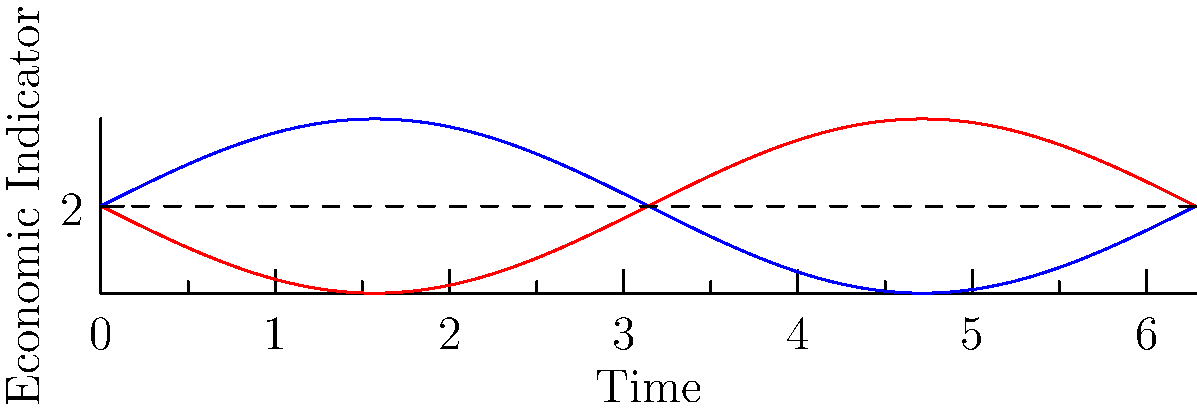Consider the time series data represented by the blue curve in the graph, which shows economic fluctuations around a trend line (dashed). The red curve represents the reflection of the original series across the trend line. What economic insight can be gained by analyzing the symmetry between these two curves, and how might this reflection technique be used in econometric modeling to assess the nature of economic cycles? To answer this question, we need to consider several aspects of the graph and its economic implications:

1. Trend line: The dashed line represents the long-term trend of the economic indicator. In econometric modeling, this could be interpreted as the potential output or equilibrium level.

2. Original series (blue): This represents the actual observed economic data, showing cyclical fluctuations around the trend.

3. Reflected series (red): This is the mirror image of the original series across the trend line.

4. Symmetry analysis:
   a) Perfect symmetry would indicate that expansions and contractions in the economic cycle are balanced in magnitude and duration.
   b) Asymmetry could suggest different characteristics for expansions versus contractions.

5. Econometric modeling implications:
   a) Symmetry could support the use of linear models or symmetric loss functions.
   b) Asymmetry might require non-linear models or asymmetric loss functions to capture the true nature of economic cycles.

6. Cycle characteristics:
   a) The amplitude of fluctuations can be measured by the vertical distance between the curves and the trend line.
   b) The frequency of cycles can be observed by the horizontal distance between peaks or troughs.

7. Policy implications:
   a) Symmetric cycles might suggest balanced policy responses for both expansions and contractions.
   b) Asymmetric cycles could imply the need for different policy approaches depending on the phase of the cycle.

8. Structural changes:
   a) Changes in symmetry over time could indicate structural shifts in the economy.
   b) This technique could be used to identify and analyze such shifts.

By applying this reflection technique and analyzing the resulting symmetry (or lack thereof), economists can gain insights into the nature of economic cycles, improve their econometric models, and potentially enhance policy recommendations.
Answer: Reflection analysis reveals cycle symmetry, informing model choice (linear vs. non-linear), loss function specification, and policy design in econometric modeling of economic cycles. 